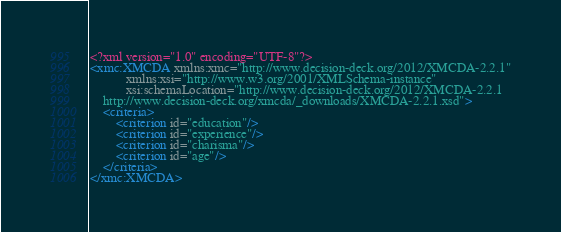Convert code to text. <code><loc_0><loc_0><loc_500><loc_500><_XML_><?xml version="1.0" encoding="UTF-8"?>
<xmc:XMCDA xmlns:xmc="http://www.decision-deck.org/2012/XMCDA-2.2.1"
           xmlns:xsi="http://www.w3.org/2001/XMLSchema-instance"
           xsi:schemaLocation="http://www.decision-deck.org/2012/XMCDA-2.2.1
	http://www.decision-deck.org/xmcda/_downloads/XMCDA-2.2.1.xsd">
    <criteria>
        <criterion id="education"/>
        <criterion id="experience"/>
        <criterion id="charisma"/>
        <criterion id="age"/>
    </criteria>
</xmc:XMCDA>
</code> 